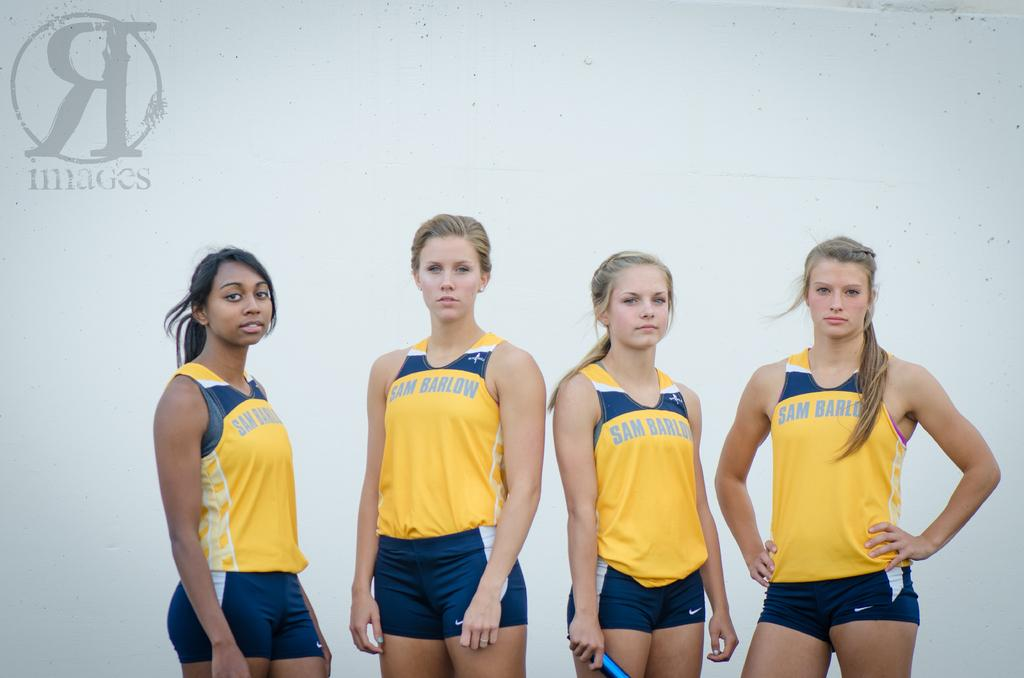<image>
Render a clear and concise summary of the photo. a team of girls with jerseys that say 'sam barlow' on them 